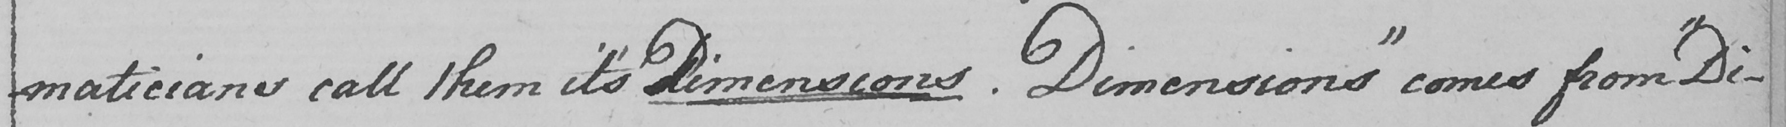What is written in this line of handwriting? maticians call them it ' s dimensions . Dimensions "  comes from  " Di- 